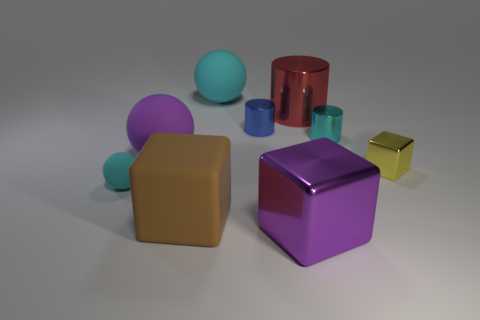Subtract all shiny cubes. How many cubes are left? 1 Add 1 big red spheres. How many objects exist? 10 Subtract all blue cylinders. How many cylinders are left? 2 Subtract 2 blocks. How many blocks are left? 1 Subtract all brown balls. Subtract all yellow cylinders. How many balls are left? 3 Subtract all green cylinders. How many yellow blocks are left? 1 Add 4 tiny cyan matte objects. How many tiny cyan matte objects are left? 5 Add 4 tiny cyan metallic things. How many tiny cyan metallic things exist? 5 Subtract 0 brown cylinders. How many objects are left? 9 Subtract all cubes. How many objects are left? 6 